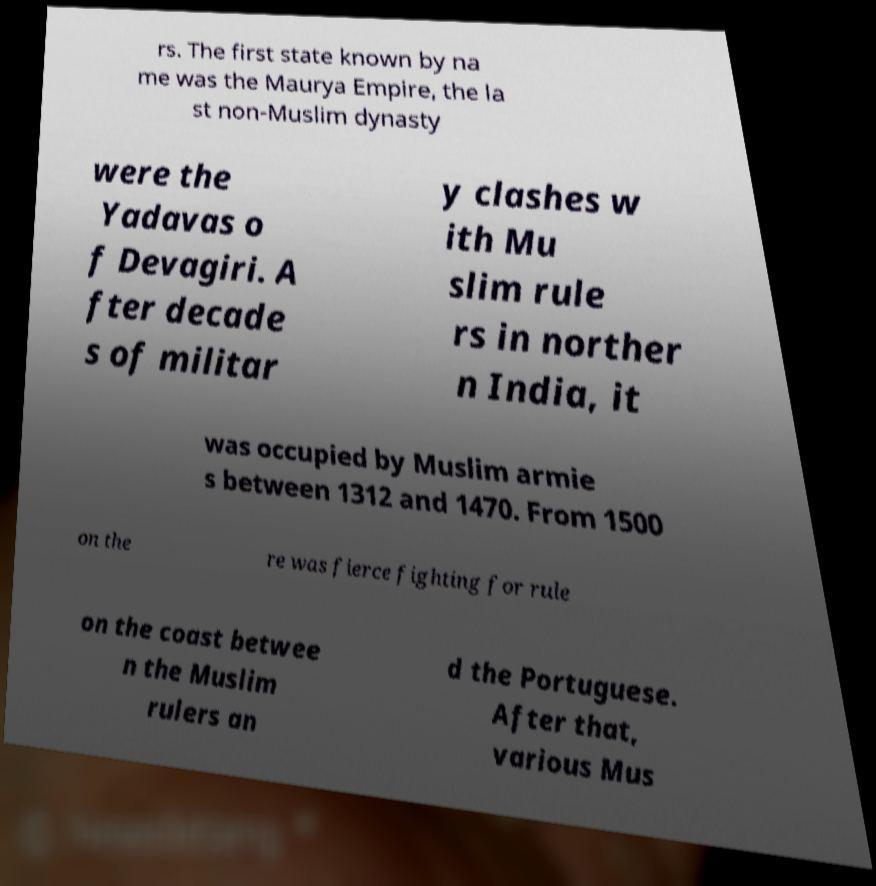I need the written content from this picture converted into text. Can you do that? rs. The first state known by na me was the Maurya Empire, the la st non-Muslim dynasty were the Yadavas o f Devagiri. A fter decade s of militar y clashes w ith Mu slim rule rs in norther n India, it was occupied by Muslim armie s between 1312 and 1470. From 1500 on the re was fierce fighting for rule on the coast betwee n the Muslim rulers an d the Portuguese. After that, various Mus 